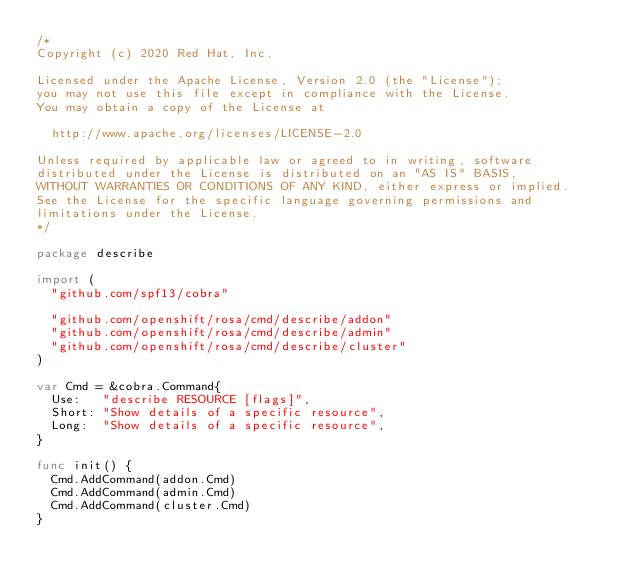Convert code to text. <code><loc_0><loc_0><loc_500><loc_500><_Go_>/*
Copyright (c) 2020 Red Hat, Inc.

Licensed under the Apache License, Version 2.0 (the "License");
you may not use this file except in compliance with the License.
You may obtain a copy of the License at

  http://www.apache.org/licenses/LICENSE-2.0

Unless required by applicable law or agreed to in writing, software
distributed under the License is distributed on an "AS IS" BASIS,
WITHOUT WARRANTIES OR CONDITIONS OF ANY KIND, either express or implied.
See the License for the specific language governing permissions and
limitations under the License.
*/

package describe

import (
	"github.com/spf13/cobra"

	"github.com/openshift/rosa/cmd/describe/addon"
	"github.com/openshift/rosa/cmd/describe/admin"
	"github.com/openshift/rosa/cmd/describe/cluster"
)

var Cmd = &cobra.Command{
	Use:   "describe RESOURCE [flags]",
	Short: "Show details of a specific resource",
	Long:  "Show details of a specific resource",
}

func init() {
	Cmd.AddCommand(addon.Cmd)
	Cmd.AddCommand(admin.Cmd)
	Cmd.AddCommand(cluster.Cmd)
}
</code> 